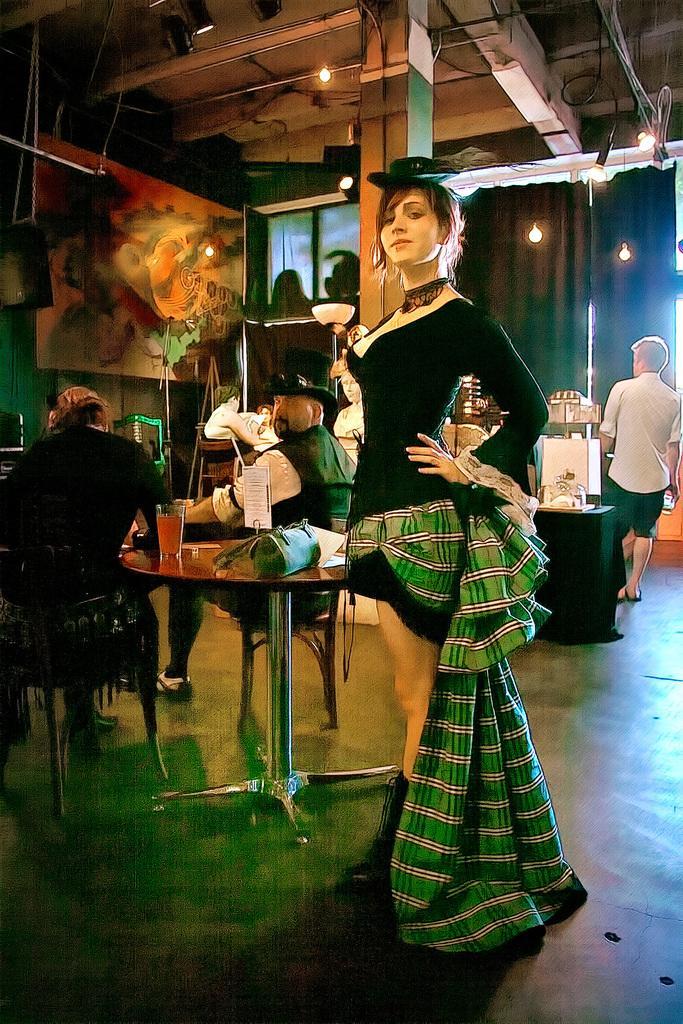Can you describe this image briefly? There is a group of people. There is a table. There is a bag and glass on a table. Some persons are sitting on a chairs. Some people are standing. 